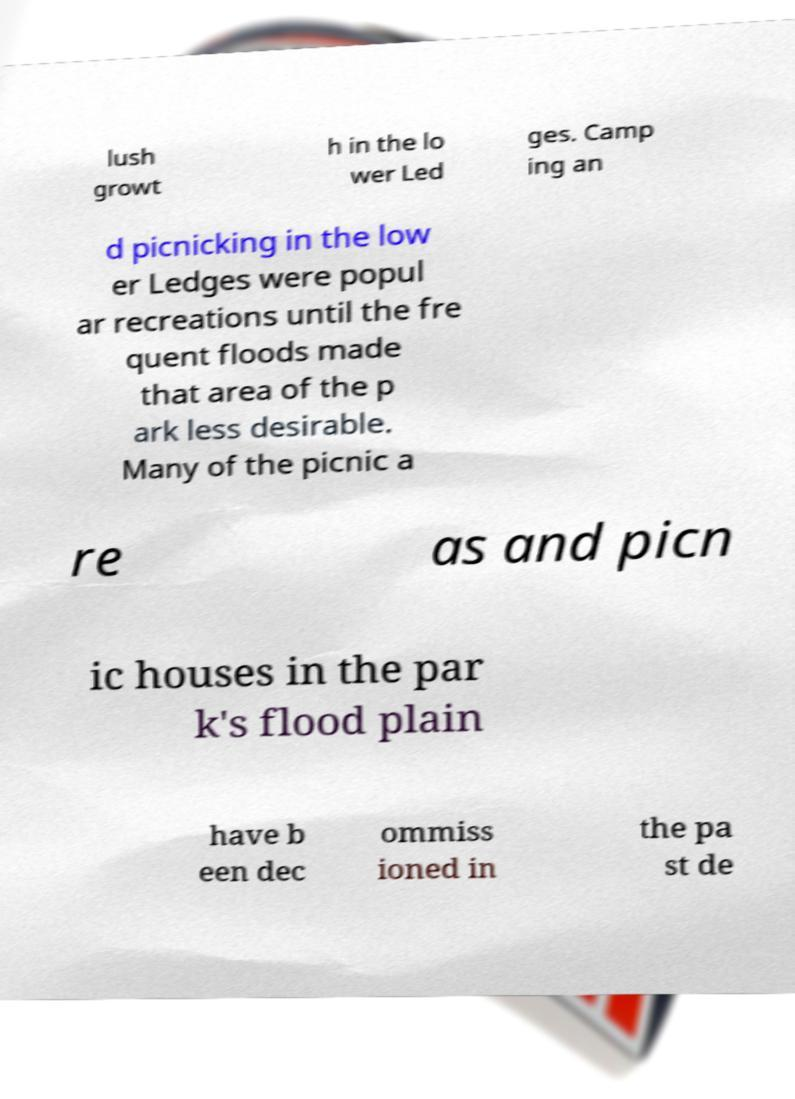For documentation purposes, I need the text within this image transcribed. Could you provide that? lush growt h in the lo wer Led ges. Camp ing an d picnicking in the low er Ledges were popul ar recreations until the fre quent floods made that area of the p ark less desirable. Many of the picnic a re as and picn ic houses in the par k's flood plain have b een dec ommiss ioned in the pa st de 